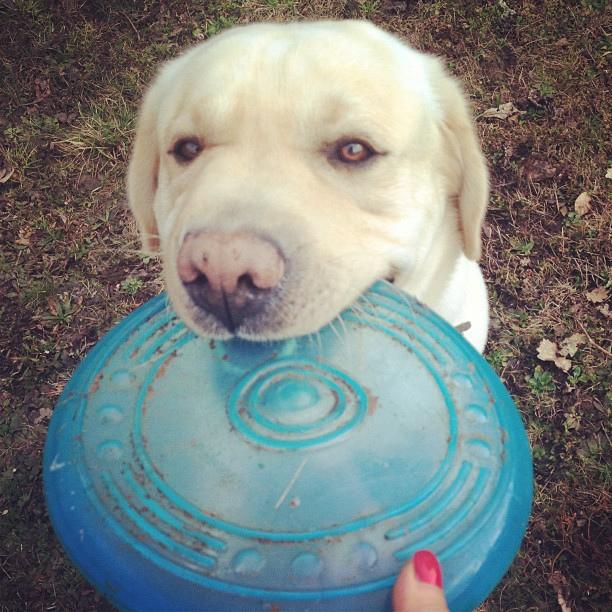What color is the nail polish on the woman's finger?
Quick response, please. Red. Does a woman throw the Frisbee?
Concise answer only. Yes. What color is the frisbee?
Write a very short answer. Blue. 